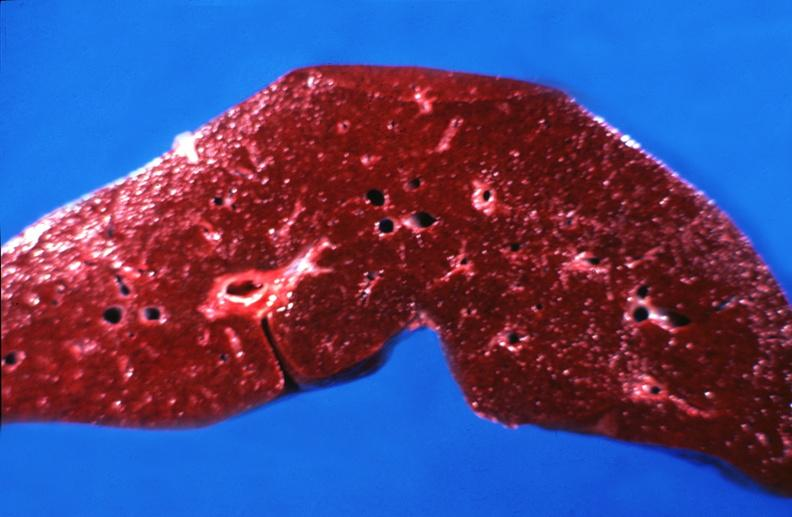does this image show hemochromatosis?
Answer the question using a single word or phrase. Yes 